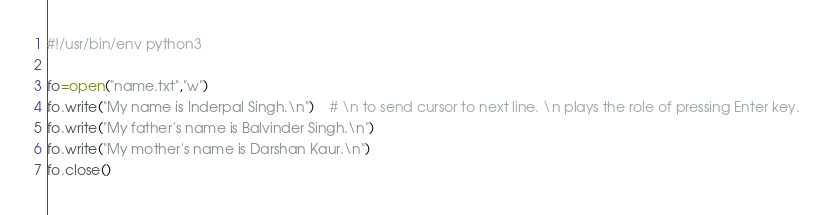<code> <loc_0><loc_0><loc_500><loc_500><_Python_>#!/usr/bin/env python3

fo=open("name.txt","w")
fo.write("My name is Inderpal Singh.\n")	# \n to send cursor to next line. \n plays the role of pressing Enter key.
fo.write("My father's name is Balvinder Singh.\n")
fo.write("My mother's name is Darshan Kaur.\n")
fo.close()
</code> 